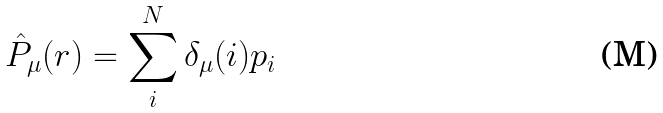<formula> <loc_0><loc_0><loc_500><loc_500>\hat { P } _ { \mu } ( r ) & = \sum _ { i } ^ { N } \delta _ { \mu } ( i ) { p } _ { i }</formula> 